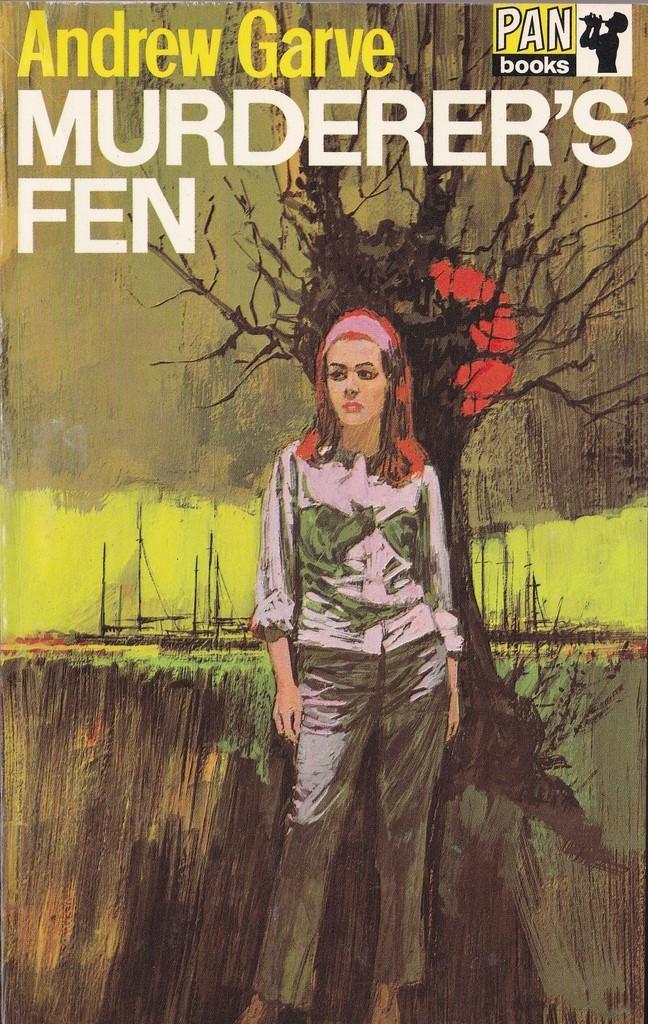In one or two sentences, can you explain what this image depicts? This picture might be a painting in the book. In this image, in the middle, we can see a woman standing. In the background, we can see some trees and a text written in the book. 